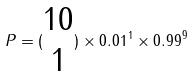<formula> <loc_0><loc_0><loc_500><loc_500>P = ( \begin{matrix} 1 0 \\ 1 \end{matrix} ) \times 0 . 0 1 ^ { 1 } \times 0 . 9 9 ^ { 9 }</formula> 